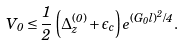<formula> <loc_0><loc_0><loc_500><loc_500>V _ { 0 } \leq \frac { 1 } { 2 } \left ( \Delta _ { z } ^ { ( 0 ) } + \epsilon _ { c } \right ) e ^ { ( G _ { 0 } l ) ^ { 2 } / 4 } .</formula> 